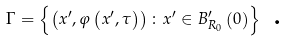<formula> <loc_0><loc_0><loc_500><loc_500>\Gamma = \left \{ \left ( x ^ { \prime } , \varphi \left ( x ^ { \prime } , \tau \right ) \right ) \colon x ^ { \prime } \in B _ { R _ { 0 } } ^ { \prime } \left ( 0 \right ) \right \} \text { .}</formula> 